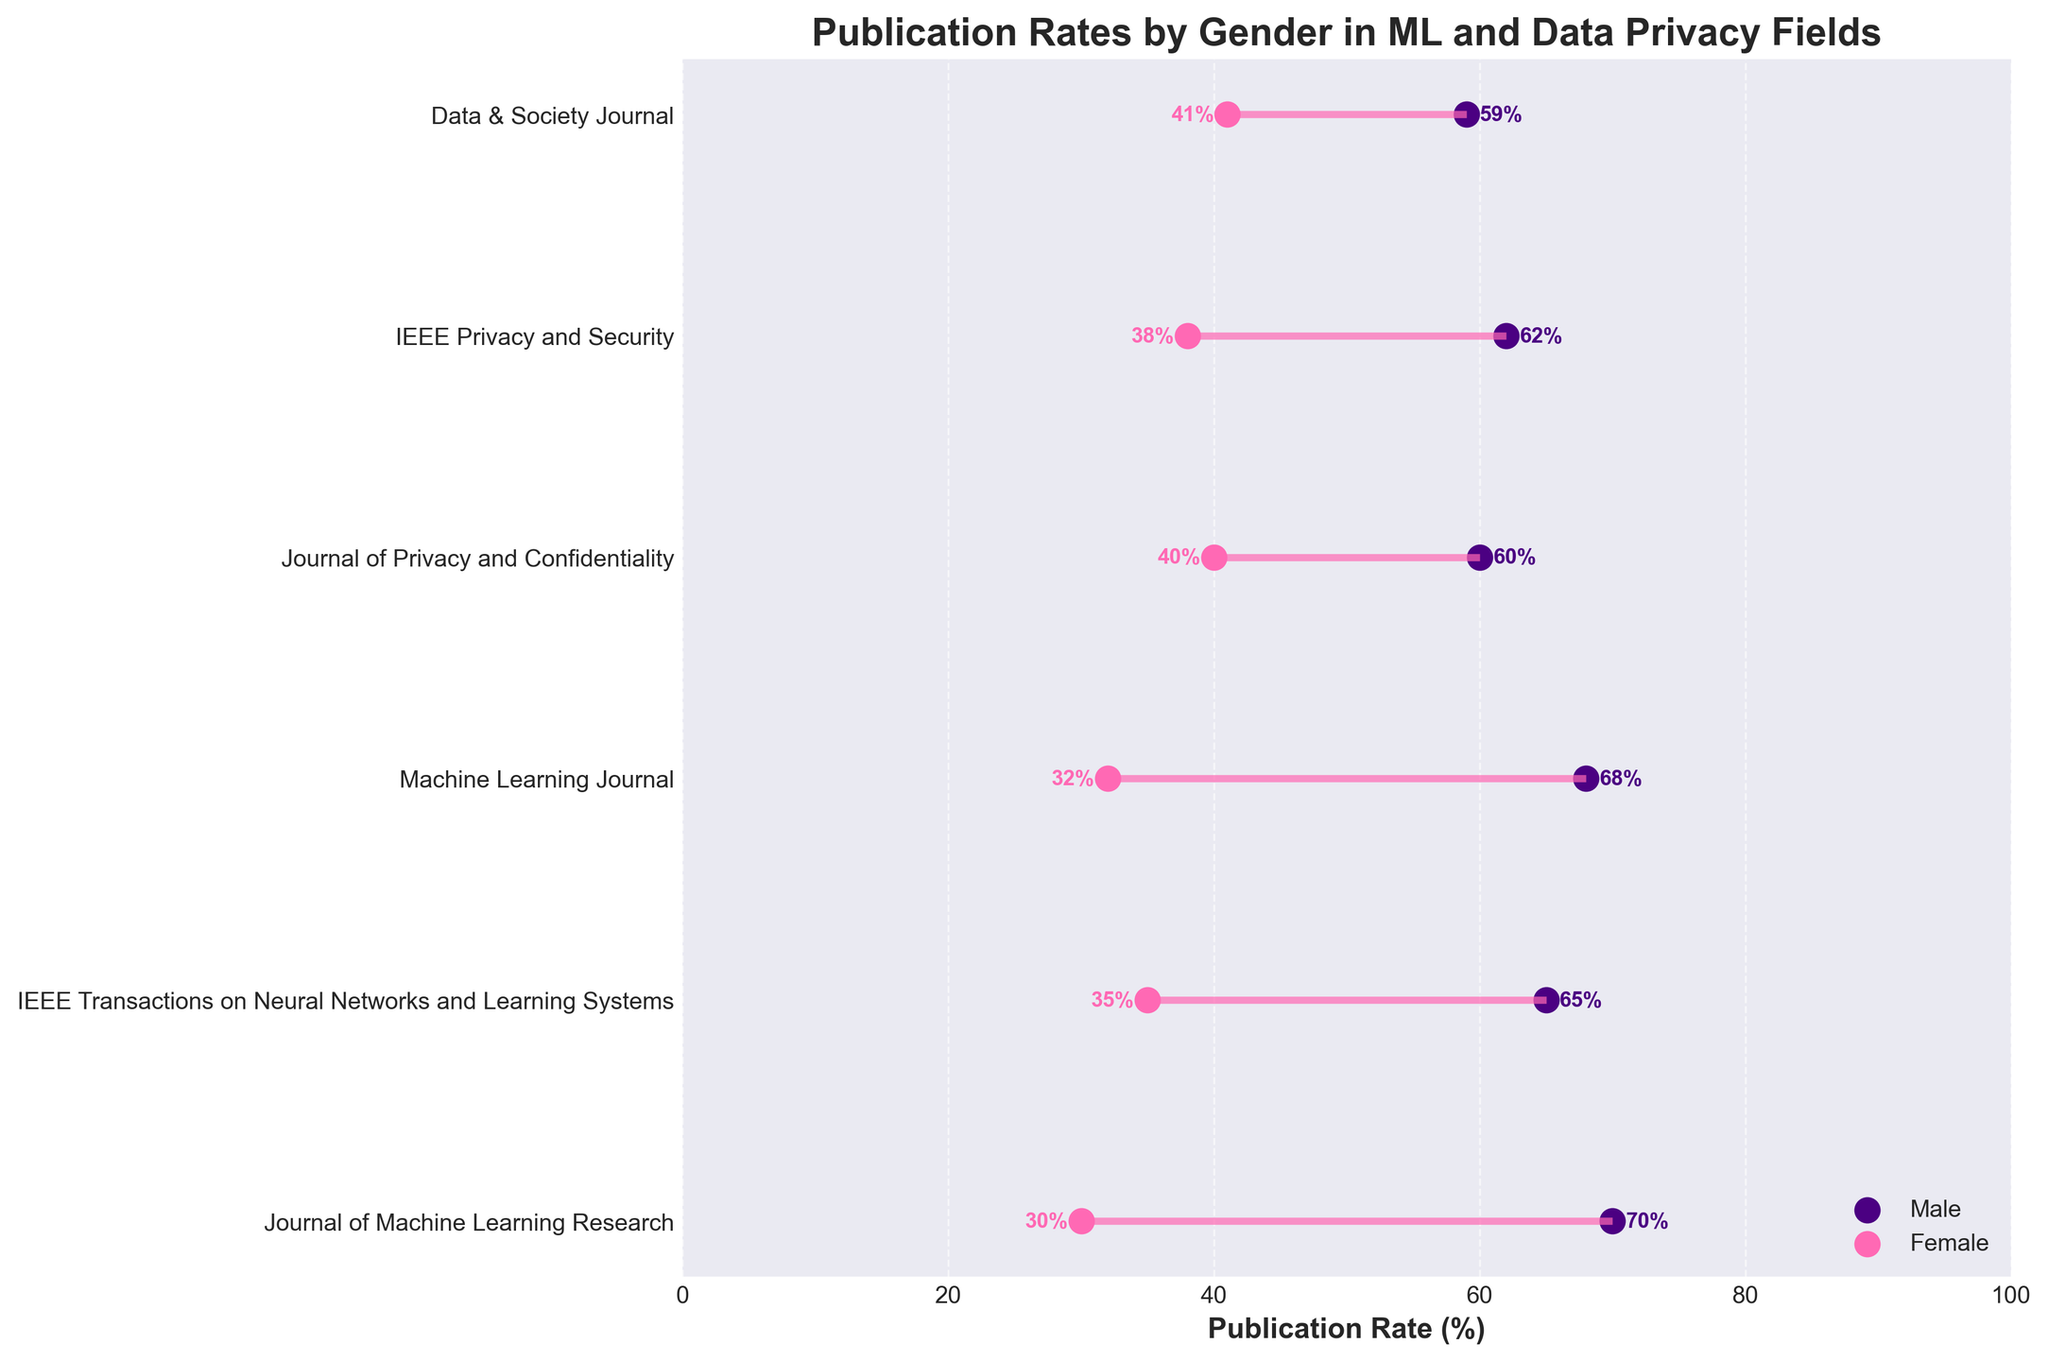What's the title of the figure? The title is typically found at the top of the figure, presenting an overview of what the visual information represents. In this case, it is about publication rates by gender in two scientific fields.
Answer: Publication Rates by Gender in ML and Data Privacy Fields How many journals are depicted in the field of Data Privacy? Count the number of data points (lines) in the plot that are labeled under the category "Data Privacy." Each line represents one journal.
Answer: 3 Which journal has the highest male publication rate? Compare the male publication rates for each journal by looking at the points that represent males in the figure and identify the journal with the highest value.
Answer: Journal of Machine Learning Research What's the average male publication rate for journals in the Machine Learning field? Add the male publication rates for all Machine Learning journals and divide by the number of journals in this field. The rates are 70, 65, and 68. Calculation: (70 + 65 + 68) / 3 = 67.67.
Answer: 67.67% How much higher is the male publication rate than the female publication rate for IEEE Privacy and Security? Find the difference between the male and female publication rates for the journal "IEEE Privacy and Security." The rates are 62 for males and 38 for females. Calculation: 62 - 38 = 24.
Answer: 24% Which journal has the smallest gender gap in publication rates? Look for the journal where the male and female publication rates are closest to each other. Note the gap for each journal and identify the smallest one.
Answer: Data & Society Journal What's the median female publication rate across all journals? List out all female publication rates (30, 35, 32, 40, 38, 41) and find the median value. As there are six data points, the median is the average of the third and fourth values when sorted (32 and 38). Calculation: (32 + 38) / 2 = 35.
Answer: 35% Which journal shows the most balanced publication rates between genders? Identify the journal where the publication rates for males and females are most balanced, meaning the smallest difference in percentages.
Answer: Data & Society Journal Is there any journal where the female publication rate exceeds 40%? Scan each marker representing female publication rates and check if any exceed 40%.
Answer: Yes, Data & Society Journal with 41% Among the Data Privacy journals, which one has the highest female publication rate? Compare the female publication rates of the Data Privacy journals to find which one is the highest.
Answer: Data & Society Journal 